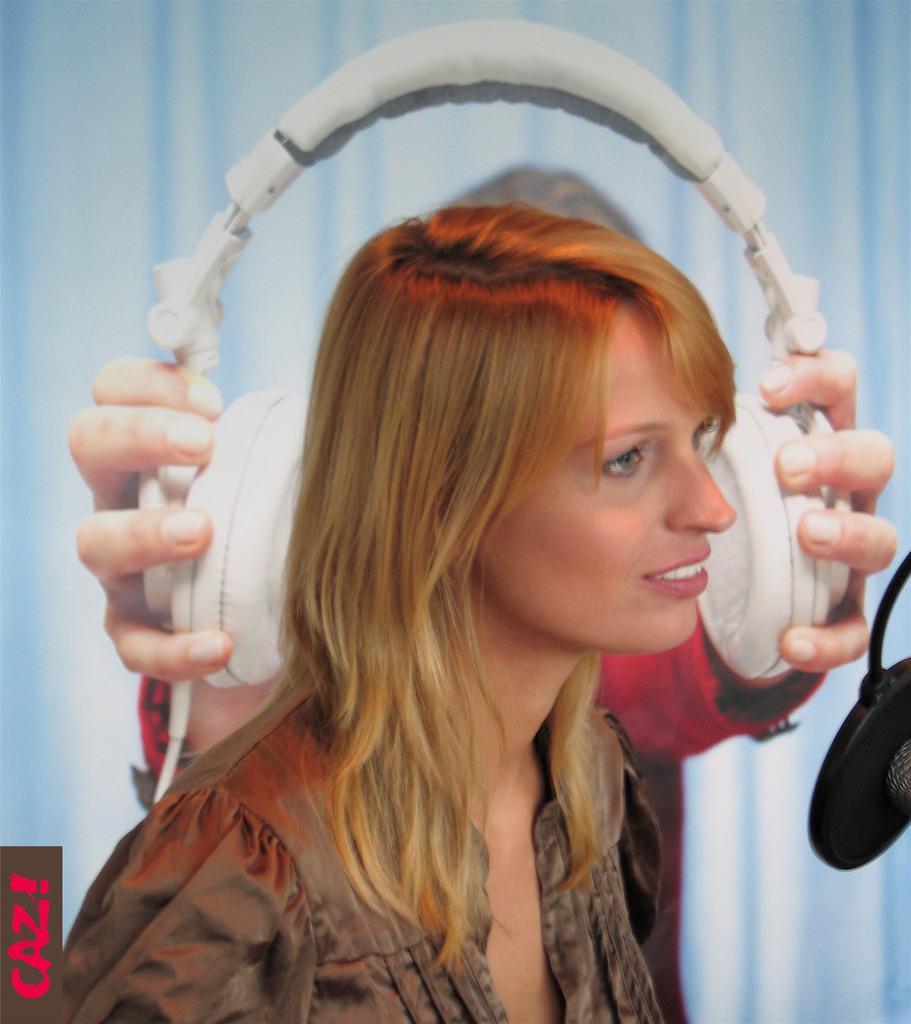Please provide a concise description of this image. In this image there is a woman. Behind there is a person holding headsets. Background there is a curtain. Right side there is an object. 